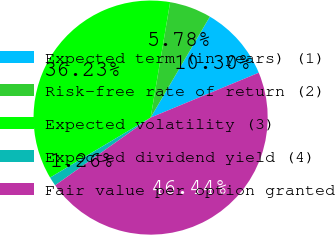Convert chart to OTSL. <chart><loc_0><loc_0><loc_500><loc_500><pie_chart><fcel>Expected term (in years) (1)<fcel>Risk-free rate of return (2)<fcel>Expected volatility (3)<fcel>Expected dividend yield (4)<fcel>Fair value per option granted<nl><fcel>10.3%<fcel>5.78%<fcel>36.23%<fcel>1.26%<fcel>46.44%<nl></chart> 